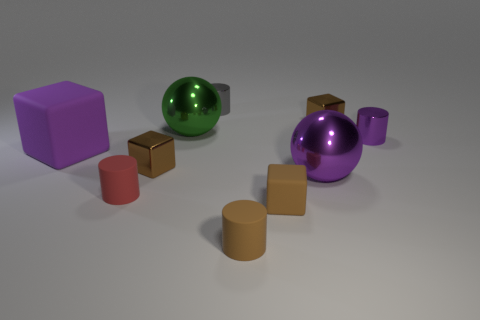Subtract all red cylinders. How many brown blocks are left? 3 Subtract 1 cubes. How many cubes are left? 3 Subtract all blocks. How many objects are left? 6 Add 4 small purple metal objects. How many small purple metal objects are left? 5 Add 7 green metal objects. How many green metal objects exist? 8 Subtract 0 gray blocks. How many objects are left? 10 Subtract all cyan rubber cylinders. Subtract all tiny brown matte blocks. How many objects are left? 9 